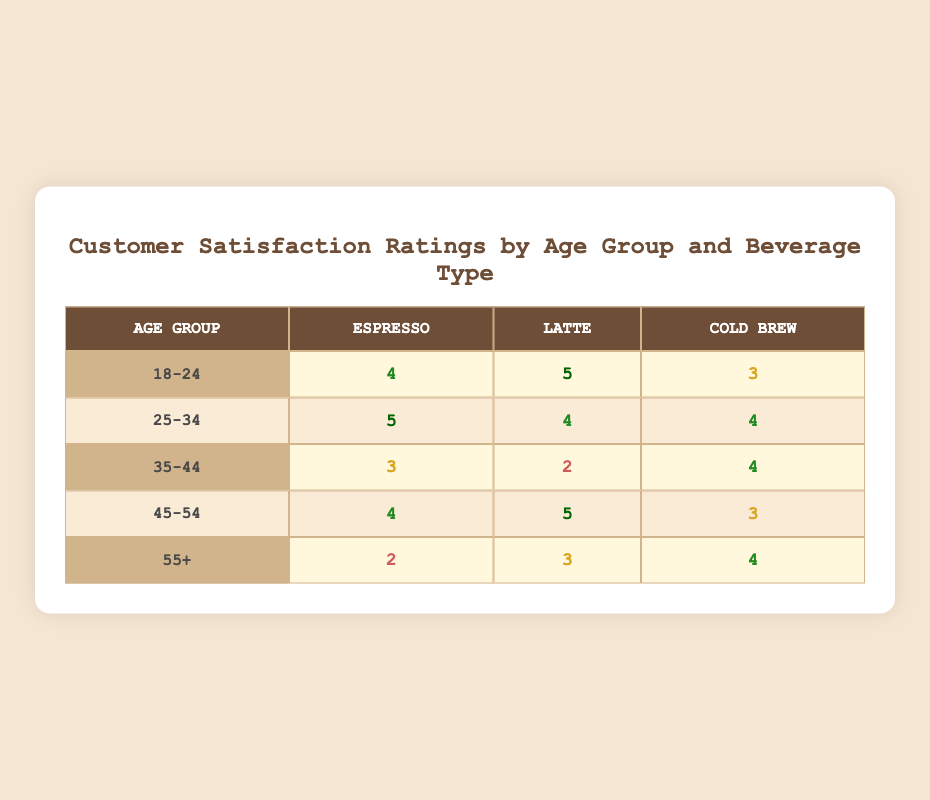What is the satisfaction rating for Cold Brew among the 25-34 age group? For the 25-34 age group, the Cold Brew row shows a satisfaction rating of 4.
Answer: 4 Which beverage type has the highest satisfaction rating in the 18-24 age group? In the 18-24 age group, the satisfaction ratings are 4 for Espresso, 5 for Latte, and 3 for Cold Brew. The highest rating is 5 for Latte.
Answer: Latte What is the average satisfaction rating for Espresso across all age groups? The satisfaction ratings for Espresso are 4 (18-24) + 5 (25-34) + 3 (35-44) + 4 (45-54) + 2 (55+) = 18. With 5 age groups, the average is 18/5 = 3.6.
Answer: 3.6 Is the satisfaction rating for Latte in the 35-44 age group higher than that for Cold Brew in the same age group? The satisfaction rating for Latte in the 35-44 age group is 2, while the rating for Cold Brew is 4. Since 2 is less than 4, the statement is false.
Answer: No Which age group has the lowest satisfaction rating for Espresso? Looking at the Espresso ratings: 4 (18-24), 5 (25-34), 3 (35-44), 4 (45-54), and 2 (55+), the lowest value is 2 in the 55+ age group.
Answer: 55+ 